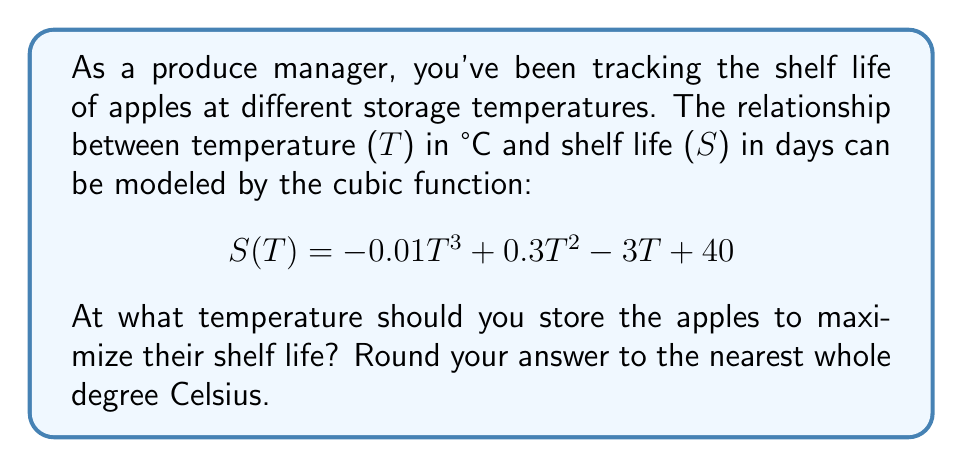Teach me how to tackle this problem. To find the temperature that maximizes the shelf life, we need to find the maximum point of the cubic function. This occurs where the derivative of the function equals zero.

1) First, let's find the derivative of S(T):
   $$ S'(T) = -0.03T^2 + 0.6T - 3 $$

2) Set the derivative equal to zero:
   $$ -0.03T^2 + 0.6T - 3 = 0 $$

3) This is a quadratic equation. We can solve it using the quadratic formula:
   $$ T = \frac{-b \pm \sqrt{b^2 - 4ac}}{2a} $$
   where $a = -0.03$, $b = 0.6$, and $c = -3$

4) Plugging in these values:
   $$ T = \frac{-0.6 \pm \sqrt{0.6^2 - 4(-0.03)(-3)}}{2(-0.03)} $$
   $$ = \frac{-0.6 \pm \sqrt{0.36 - 0.36}}{-0.06} $$
   $$ = \frac{-0.6 \pm 0}{-0.06} $$
   $$ = 10 $$

5) The second derivative is $S''(T) = -0.06T + 0.6$. At T = 10, $S''(10) = -0.06(10) + 0.6 = 0$, which is negative, confirming this is a maximum point.

6) Therefore, the shelf life is maximized at 10°C.
Answer: 10°C 